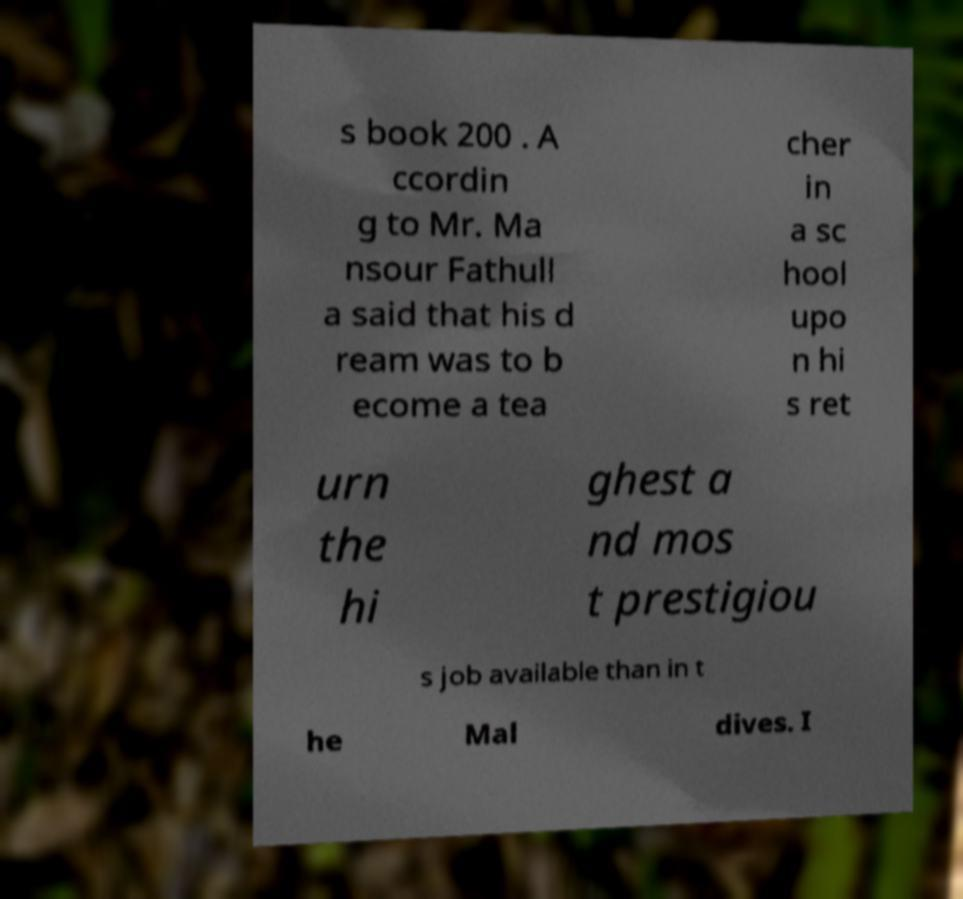There's text embedded in this image that I need extracted. Can you transcribe it verbatim? s book 200 . A ccordin g to Mr. Ma nsour Fathull a said that his d ream was to b ecome a tea cher in a sc hool upo n hi s ret urn the hi ghest a nd mos t prestigiou s job available than in t he Mal dives. I 